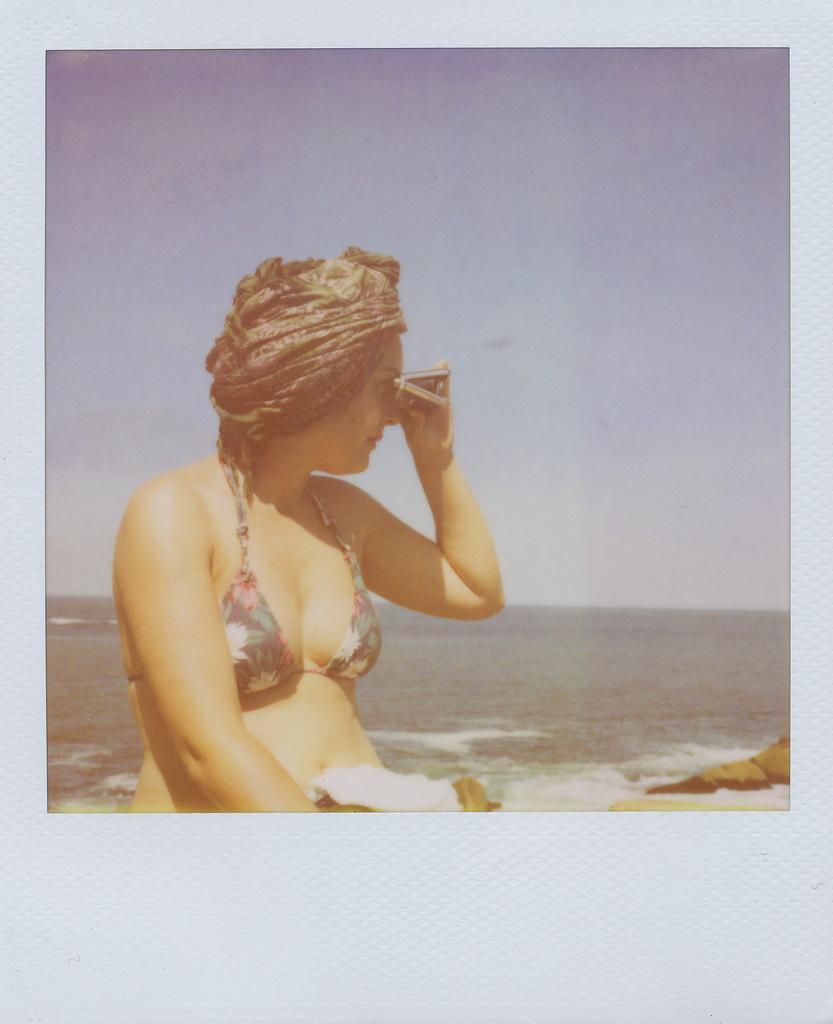How would you summarize this image in a sentence or two? This picture is an edited picture. In this image there is a woman sitting and holding the object. At the back there is sea. At the top there is sky. 